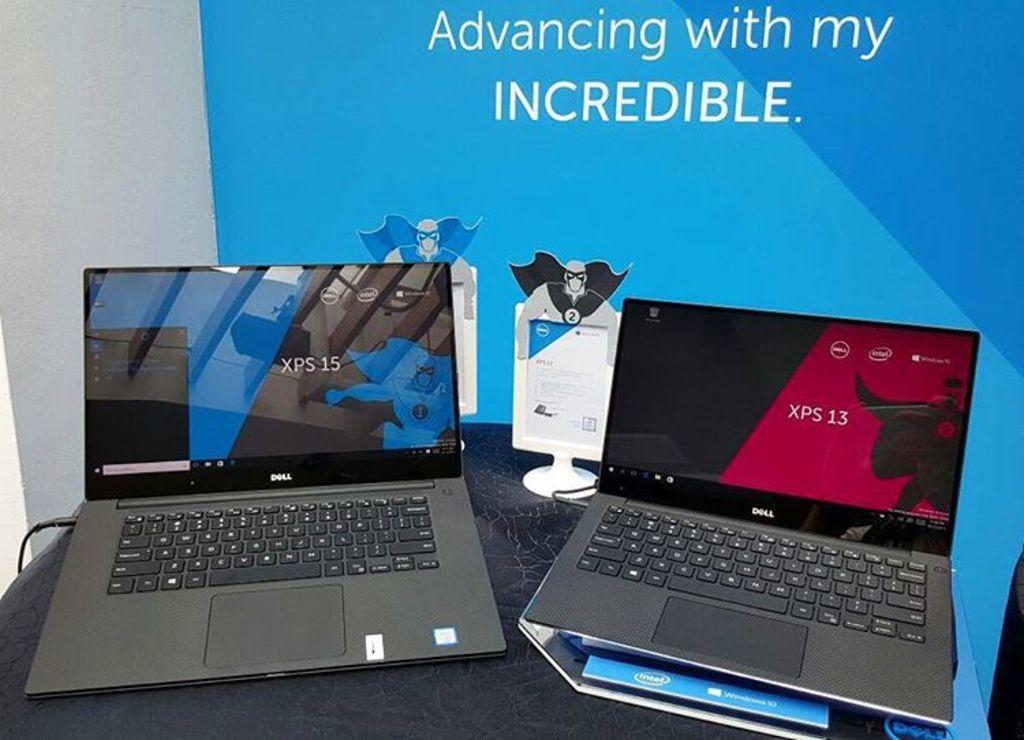What company branded the laptop?
Make the answer very short. Dell. 